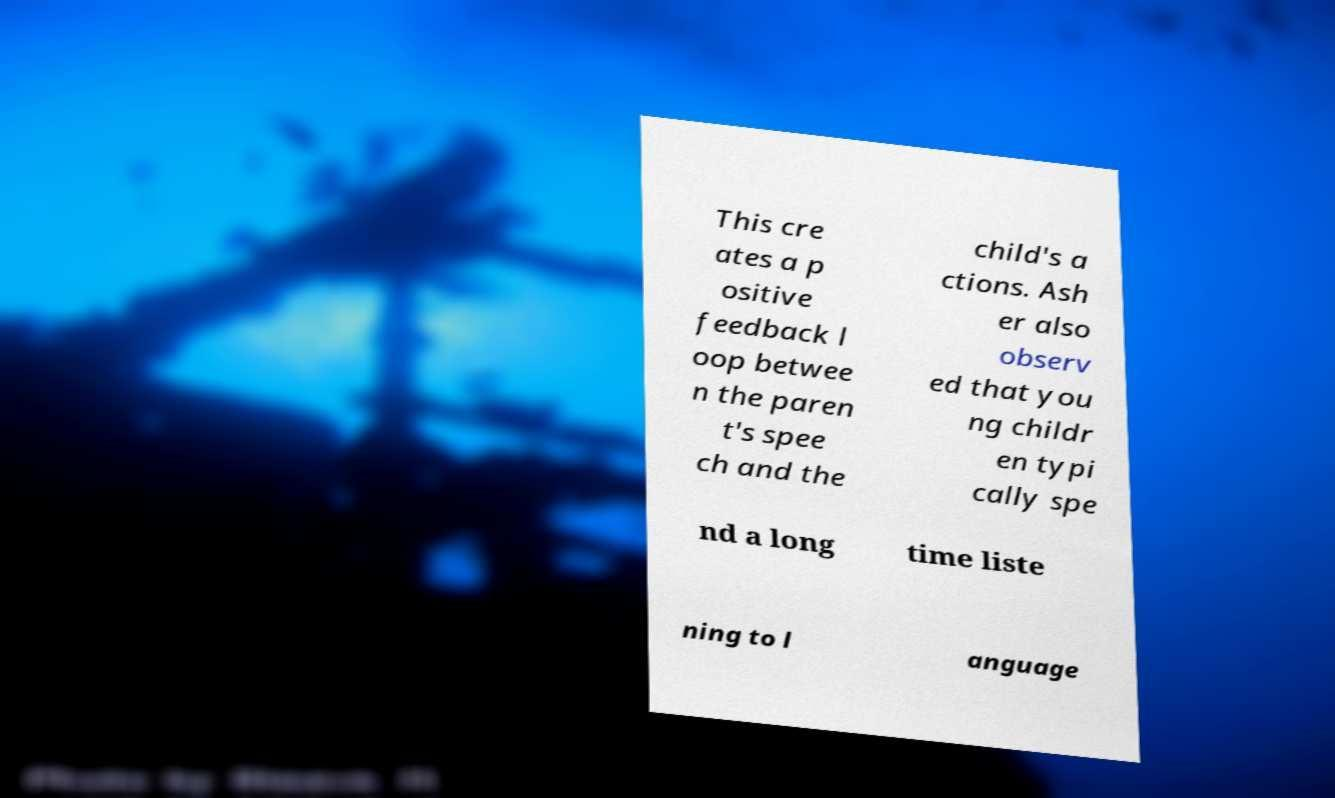Can you accurately transcribe the text from the provided image for me? This cre ates a p ositive feedback l oop betwee n the paren t's spee ch and the child's a ctions. Ash er also observ ed that you ng childr en typi cally spe nd a long time liste ning to l anguage 